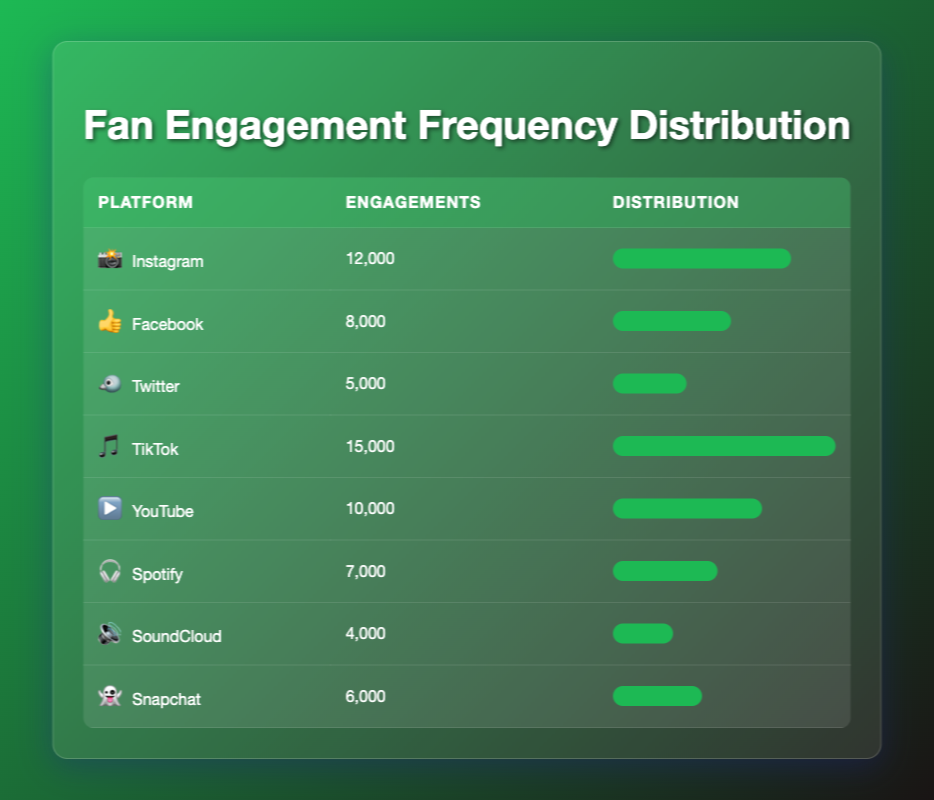What is the highest engagement level among the platforms? Looking at the table, TikTok has the highest engagement level with 15,000 engagements.
Answer: 15,000 How many engagements does Facebook have compared to Spotify? Facebook has 8,000 engagements while Spotify has 7,000. Therefore, Facebook has 1,000 more engagements than Spotify.
Answer: 1,000 Which platform has the least engagement? Among all the platforms listed, SoundCloud has the least engagement with 4,000 engagements.
Answer: 4,000 What is the average engagement level across all platforms? To find the average, first sum all engagement values: 12000 + 8000 + 5000 + 15000 + 10000 + 7000 + 4000 + 6000 = 60000. There are 8 platforms, so the average is 60000 / 8 = 7500.
Answer: 7,500 Is it true that YouTube has more engagements than both Instagram and Facebook combined? Instagram has 12,000 engagements and Facebook has 8,000, which combined is 20,000. YouTube has 10,000 engagements, which is less than the combined total of Instagram and Facebook. Therefore, it is false.
Answer: No How does TikTok engagement compare to the engagement level of the other platforms? TikTok engagement at 15,000 is higher than all other platforms, as the next highest is Instagram with 12,000. No other platform exceeds TikTok's engagement level.
Answer: Higher than all other platforms Which platform has engagements closer to the average engagement level? The average engagement level is 7,500. Platforms like Spotify with 7,000 and Snapchat with 6,000 are the closest. Spotify is only 500 below average, and Snapchat is 1,500 below, making Spotify the closest.
Answer: Spotify What is the total number of engagements from all platforms? We sum the engagements: 12000 + 8000 + 5000 + 15000 + 10000 + 7000 + 4000 + 6000 = 60000. Thus, the total engagements across all platforms is 60,000.
Answer: 60,000 